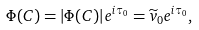<formula> <loc_0><loc_0><loc_500><loc_500>\Phi ( C ) = | \Phi ( C ) | e ^ { i \tau _ { 0 } } = \widetilde { v } _ { 0 } e ^ { i \tau _ { 0 } } ,</formula> 